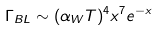Convert formula to latex. <formula><loc_0><loc_0><loc_500><loc_500>\Gamma _ { B L } \sim ( \alpha _ { W } T ) ^ { 4 } x ^ { 7 } e ^ { - x }</formula> 